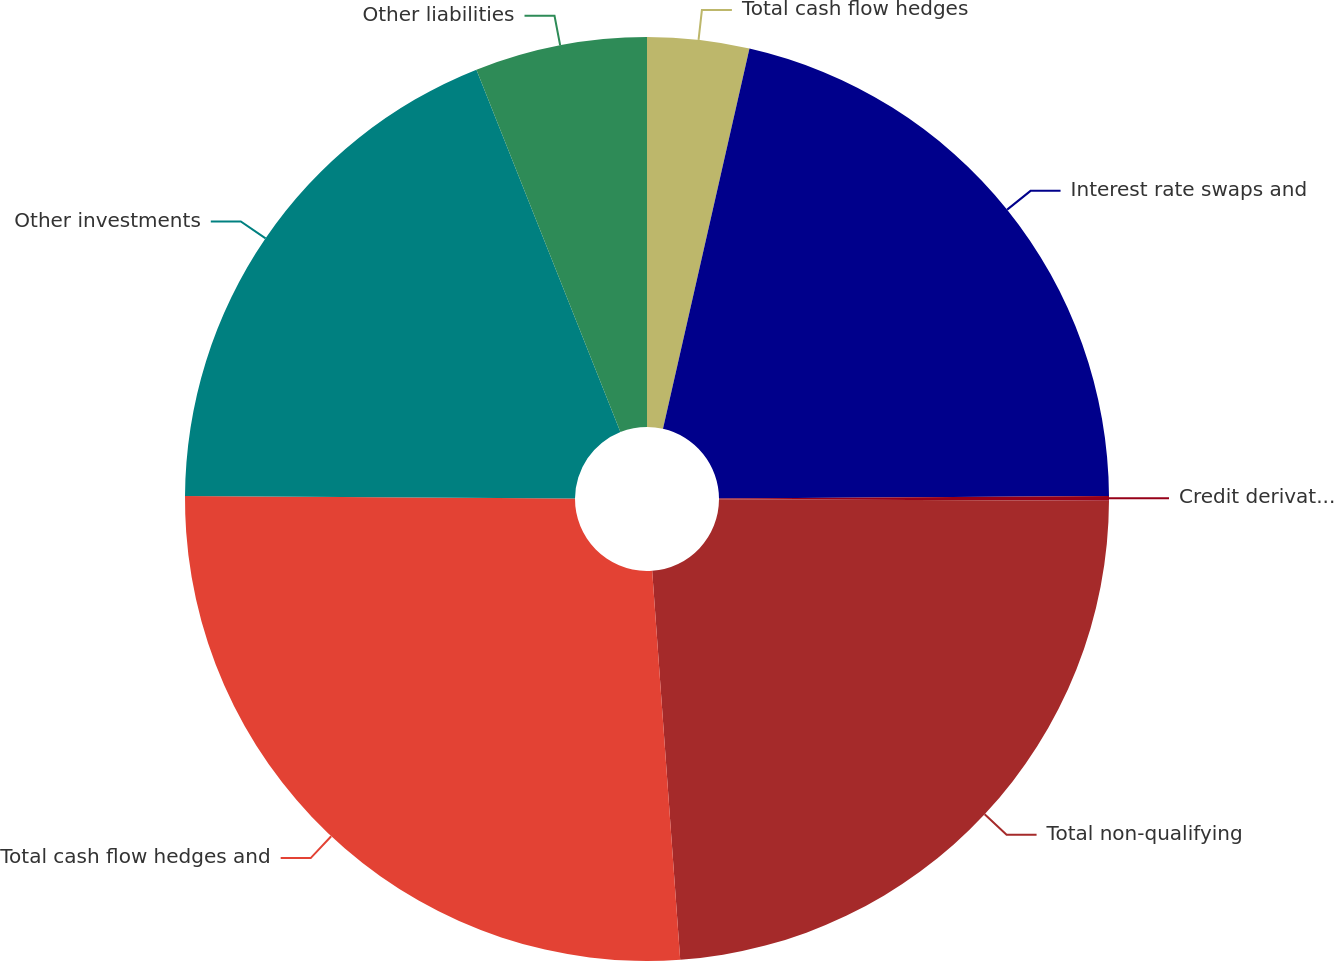<chart> <loc_0><loc_0><loc_500><loc_500><pie_chart><fcel>Total cash flow hedges<fcel>Interest rate swaps and<fcel>Credit derivatives that assume<fcel>Total non-qualifying<fcel>Total cash flow hedges and<fcel>Other investments<fcel>Other liabilities<nl><fcel>3.56%<fcel>21.34%<fcel>0.16%<fcel>23.8%<fcel>26.25%<fcel>18.88%<fcel>6.02%<nl></chart> 